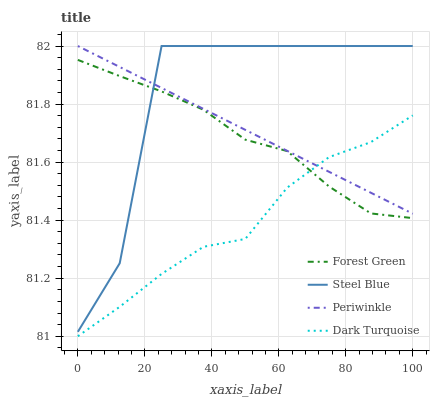Does Dark Turquoise have the minimum area under the curve?
Answer yes or no. Yes. Does Steel Blue have the maximum area under the curve?
Answer yes or no. Yes. Does Forest Green have the minimum area under the curve?
Answer yes or no. No. Does Forest Green have the maximum area under the curve?
Answer yes or no. No. Is Periwinkle the smoothest?
Answer yes or no. Yes. Is Steel Blue the roughest?
Answer yes or no. Yes. Is Forest Green the smoothest?
Answer yes or no. No. Is Forest Green the roughest?
Answer yes or no. No. Does Dark Turquoise have the lowest value?
Answer yes or no. Yes. Does Forest Green have the lowest value?
Answer yes or no. No. Does Steel Blue have the highest value?
Answer yes or no. Yes. Does Forest Green have the highest value?
Answer yes or no. No. Is Dark Turquoise less than Steel Blue?
Answer yes or no. Yes. Is Steel Blue greater than Dark Turquoise?
Answer yes or no. Yes. Does Forest Green intersect Steel Blue?
Answer yes or no. Yes. Is Forest Green less than Steel Blue?
Answer yes or no. No. Is Forest Green greater than Steel Blue?
Answer yes or no. No. Does Dark Turquoise intersect Steel Blue?
Answer yes or no. No. 